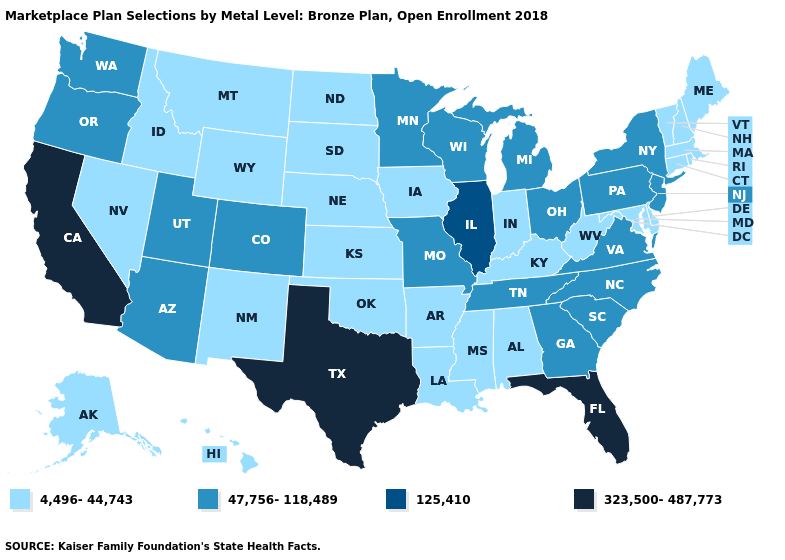Among the states that border Maine , which have the lowest value?
Write a very short answer. New Hampshire. Which states have the lowest value in the South?
Quick response, please. Alabama, Arkansas, Delaware, Kentucky, Louisiana, Maryland, Mississippi, Oklahoma, West Virginia. What is the lowest value in the USA?
Give a very brief answer. 4,496-44,743. Is the legend a continuous bar?
Concise answer only. No. Does Rhode Island have a lower value than Arkansas?
Be succinct. No. Name the states that have a value in the range 323,500-487,773?
Be succinct. California, Florida, Texas. Which states have the lowest value in the USA?
Concise answer only. Alabama, Alaska, Arkansas, Connecticut, Delaware, Hawaii, Idaho, Indiana, Iowa, Kansas, Kentucky, Louisiana, Maine, Maryland, Massachusetts, Mississippi, Montana, Nebraska, Nevada, New Hampshire, New Mexico, North Dakota, Oklahoma, Rhode Island, South Dakota, Vermont, West Virginia, Wyoming. Name the states that have a value in the range 47,756-118,489?
Write a very short answer. Arizona, Colorado, Georgia, Michigan, Minnesota, Missouri, New Jersey, New York, North Carolina, Ohio, Oregon, Pennsylvania, South Carolina, Tennessee, Utah, Virginia, Washington, Wisconsin. Name the states that have a value in the range 323,500-487,773?
Be succinct. California, Florida, Texas. What is the value of Delaware?
Quick response, please. 4,496-44,743. Does the map have missing data?
Concise answer only. No. What is the highest value in the USA?
Keep it brief. 323,500-487,773. What is the value of California?
Quick response, please. 323,500-487,773. What is the highest value in the Northeast ?
Be succinct. 47,756-118,489. What is the value of North Carolina?
Be succinct. 47,756-118,489. 